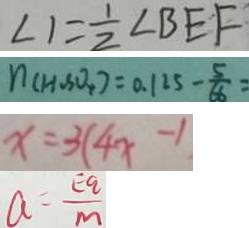Convert formula to latex. <formula><loc_0><loc_0><loc_500><loc_500>\angle 1 = \frac { 1 } { 2 } \angle B E F 
 n ( H _ { 2 } S O _ { 4 } ) = 0 . 1 2 5 - \frac { 5 } { 6 6 } = 
 x = 3 ( 4 x - 1 
 a = \frac { E q } { m }</formula> 